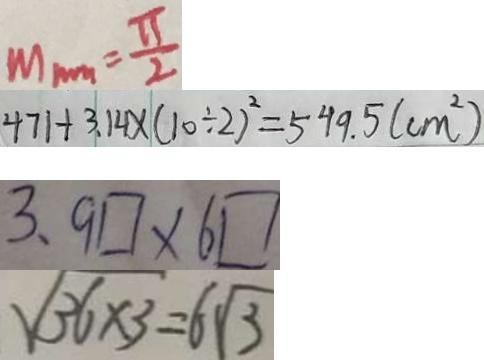Convert formula to latex. <formula><loc_0><loc_0><loc_500><loc_500>M _ { \min } = \frac { \pi } { 2 } 
 4 7 1 + 3 . 1 4 \times ( 1 0 \div 2 ) ^ { 2 } = 5 4 9 . 5 ( c m ^ { 2 } ) 
 3 、 9 \square \times 6 \square 
 \sqrt { 3 6 \times 3 } = 6 \sqrt { 3 }</formula> 